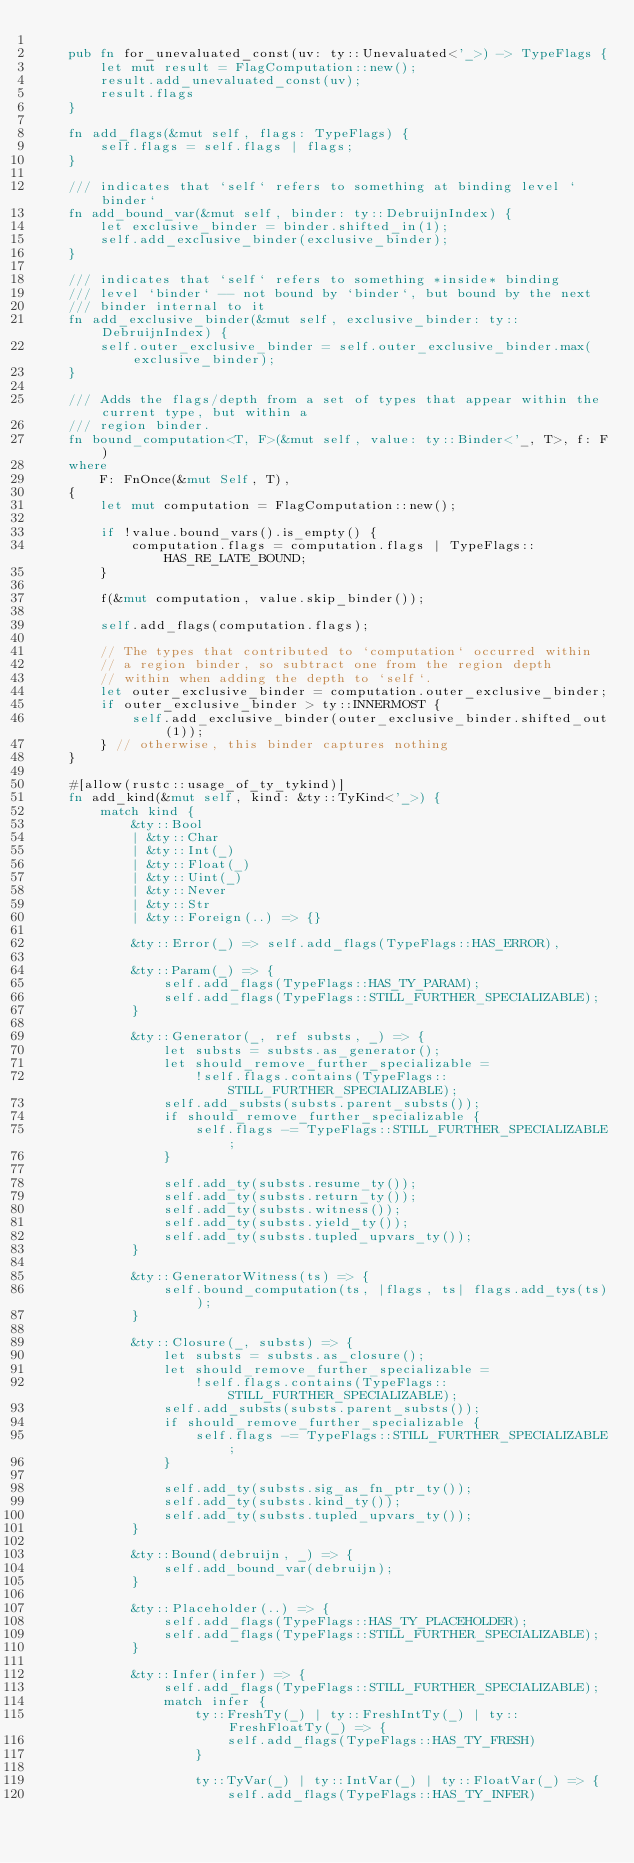Convert code to text. <code><loc_0><loc_0><loc_500><loc_500><_Rust_>
    pub fn for_unevaluated_const(uv: ty::Unevaluated<'_>) -> TypeFlags {
        let mut result = FlagComputation::new();
        result.add_unevaluated_const(uv);
        result.flags
    }

    fn add_flags(&mut self, flags: TypeFlags) {
        self.flags = self.flags | flags;
    }

    /// indicates that `self` refers to something at binding level `binder`
    fn add_bound_var(&mut self, binder: ty::DebruijnIndex) {
        let exclusive_binder = binder.shifted_in(1);
        self.add_exclusive_binder(exclusive_binder);
    }

    /// indicates that `self` refers to something *inside* binding
    /// level `binder` -- not bound by `binder`, but bound by the next
    /// binder internal to it
    fn add_exclusive_binder(&mut self, exclusive_binder: ty::DebruijnIndex) {
        self.outer_exclusive_binder = self.outer_exclusive_binder.max(exclusive_binder);
    }

    /// Adds the flags/depth from a set of types that appear within the current type, but within a
    /// region binder.
    fn bound_computation<T, F>(&mut self, value: ty::Binder<'_, T>, f: F)
    where
        F: FnOnce(&mut Self, T),
    {
        let mut computation = FlagComputation::new();

        if !value.bound_vars().is_empty() {
            computation.flags = computation.flags | TypeFlags::HAS_RE_LATE_BOUND;
        }

        f(&mut computation, value.skip_binder());

        self.add_flags(computation.flags);

        // The types that contributed to `computation` occurred within
        // a region binder, so subtract one from the region depth
        // within when adding the depth to `self`.
        let outer_exclusive_binder = computation.outer_exclusive_binder;
        if outer_exclusive_binder > ty::INNERMOST {
            self.add_exclusive_binder(outer_exclusive_binder.shifted_out(1));
        } // otherwise, this binder captures nothing
    }

    #[allow(rustc::usage_of_ty_tykind)]
    fn add_kind(&mut self, kind: &ty::TyKind<'_>) {
        match kind {
            &ty::Bool
            | &ty::Char
            | &ty::Int(_)
            | &ty::Float(_)
            | &ty::Uint(_)
            | &ty::Never
            | &ty::Str
            | &ty::Foreign(..) => {}

            &ty::Error(_) => self.add_flags(TypeFlags::HAS_ERROR),

            &ty::Param(_) => {
                self.add_flags(TypeFlags::HAS_TY_PARAM);
                self.add_flags(TypeFlags::STILL_FURTHER_SPECIALIZABLE);
            }

            &ty::Generator(_, ref substs, _) => {
                let substs = substs.as_generator();
                let should_remove_further_specializable =
                    !self.flags.contains(TypeFlags::STILL_FURTHER_SPECIALIZABLE);
                self.add_substs(substs.parent_substs());
                if should_remove_further_specializable {
                    self.flags -= TypeFlags::STILL_FURTHER_SPECIALIZABLE;
                }

                self.add_ty(substs.resume_ty());
                self.add_ty(substs.return_ty());
                self.add_ty(substs.witness());
                self.add_ty(substs.yield_ty());
                self.add_ty(substs.tupled_upvars_ty());
            }

            &ty::GeneratorWitness(ts) => {
                self.bound_computation(ts, |flags, ts| flags.add_tys(ts));
            }

            &ty::Closure(_, substs) => {
                let substs = substs.as_closure();
                let should_remove_further_specializable =
                    !self.flags.contains(TypeFlags::STILL_FURTHER_SPECIALIZABLE);
                self.add_substs(substs.parent_substs());
                if should_remove_further_specializable {
                    self.flags -= TypeFlags::STILL_FURTHER_SPECIALIZABLE;
                }

                self.add_ty(substs.sig_as_fn_ptr_ty());
                self.add_ty(substs.kind_ty());
                self.add_ty(substs.tupled_upvars_ty());
            }

            &ty::Bound(debruijn, _) => {
                self.add_bound_var(debruijn);
            }

            &ty::Placeholder(..) => {
                self.add_flags(TypeFlags::HAS_TY_PLACEHOLDER);
                self.add_flags(TypeFlags::STILL_FURTHER_SPECIALIZABLE);
            }

            &ty::Infer(infer) => {
                self.add_flags(TypeFlags::STILL_FURTHER_SPECIALIZABLE);
                match infer {
                    ty::FreshTy(_) | ty::FreshIntTy(_) | ty::FreshFloatTy(_) => {
                        self.add_flags(TypeFlags::HAS_TY_FRESH)
                    }

                    ty::TyVar(_) | ty::IntVar(_) | ty::FloatVar(_) => {
                        self.add_flags(TypeFlags::HAS_TY_INFER)</code> 